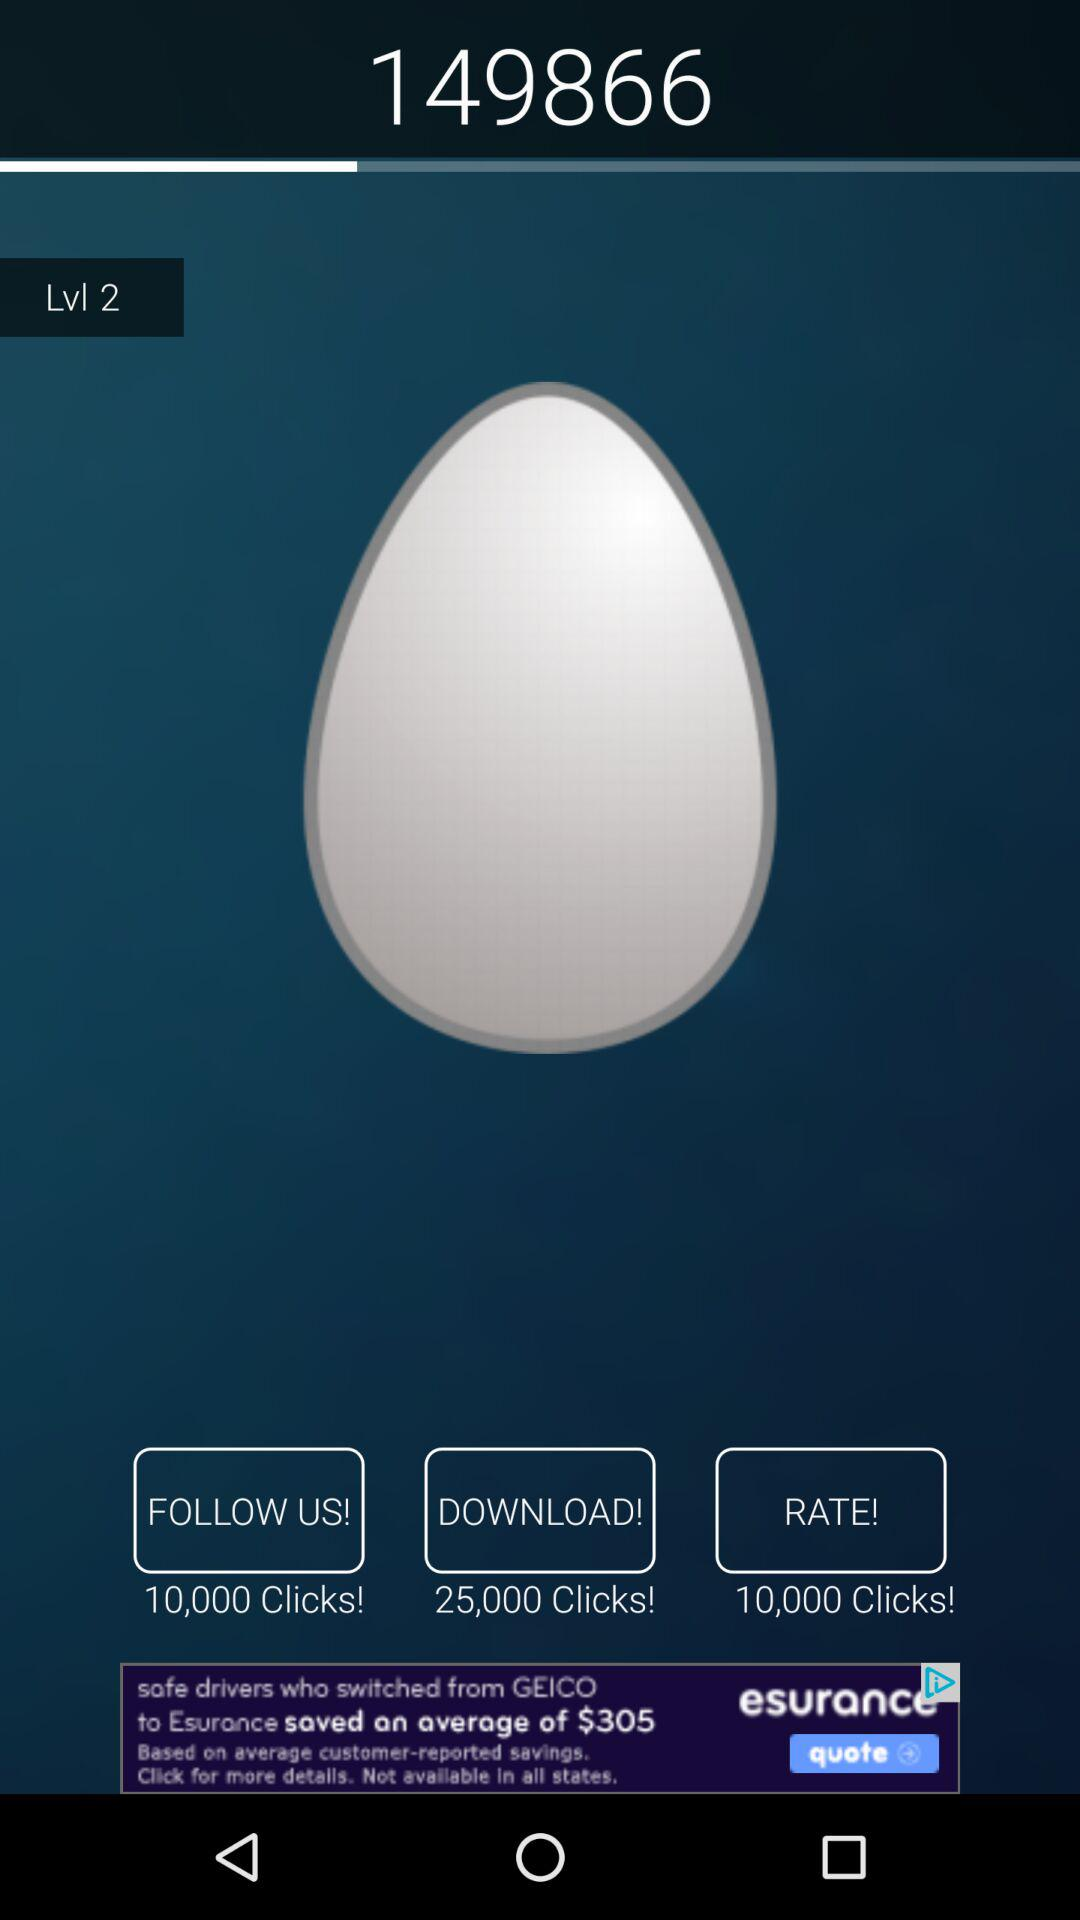How many clicks are there on the downloads? There are 25,000 clicks. 